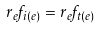Convert formula to latex. <formula><loc_0><loc_0><loc_500><loc_500>r _ { e } f _ { i ( e ) } = r _ { e } f _ { t ( e ) }</formula> 